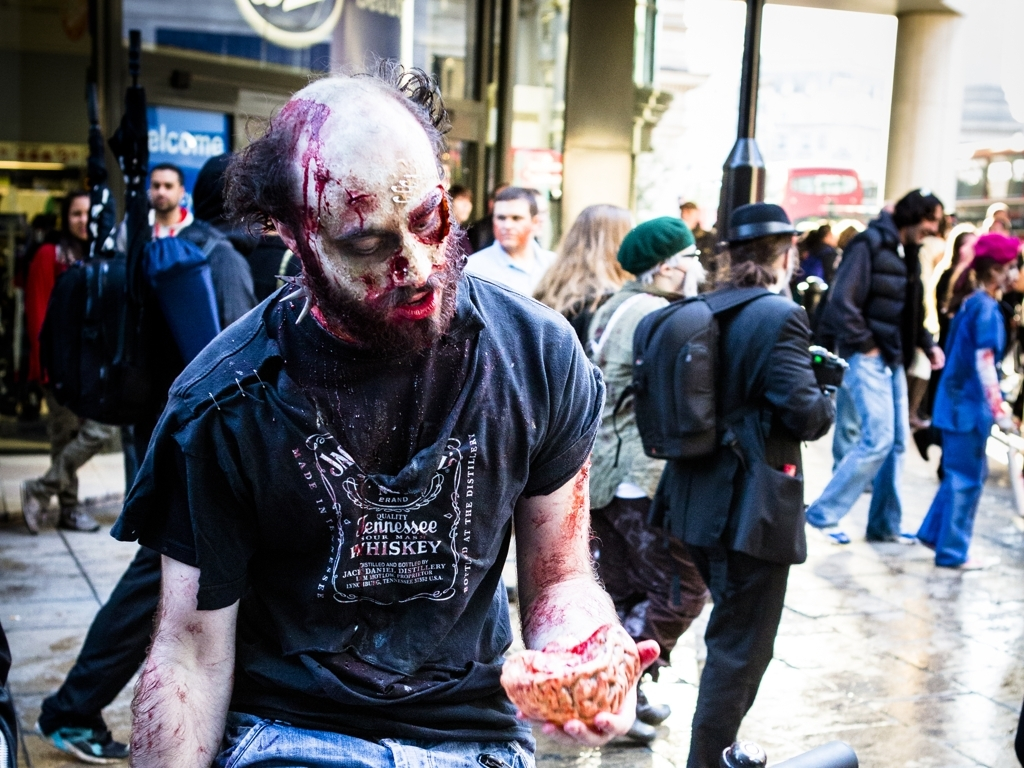What does the surrounding environment suggest about the event taking place? The surrounding environment, featuring people in everyday clothing casually walking by a storefront, suggests that the photo was taken on a busy street in an urban setting. The onlookers do not seem perturbed by the individual in zombie makeup, indicating that the event may be a known and expected one, perhaps a public gathering like a zombie walk or a Halloween celebration where attendees dress up in costume and partake in zombie-themed activities. 